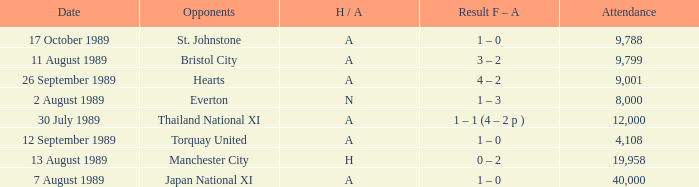Could you help me parse every detail presented in this table? {'header': ['Date', 'Opponents', 'H / A', 'Result F – A', 'Attendance'], 'rows': [['17 October 1989', 'St. Johnstone', 'A', '1 – 0', '9,788'], ['11 August 1989', 'Bristol City', 'A', '3 – 2', '9,799'], ['26 September 1989', 'Hearts', 'A', '4 – 2', '9,001'], ['2 August 1989', 'Everton', 'N', '1 – 3', '8,000'], ['30 July 1989', 'Thailand National XI', 'A', '1 – 1 (4 – 2 p )', '12,000'], ['12 September 1989', 'Torquay United', 'A', '1 – 0', '4,108'], ['13 August 1989', 'Manchester City', 'H', '0 – 2', '19,958'], ['7 August 1989', 'Japan National XI', 'A', '1 – 0', '40,000']]} When did Manchester United play against Bristol City with an H/A of A? 11 August 1989. 